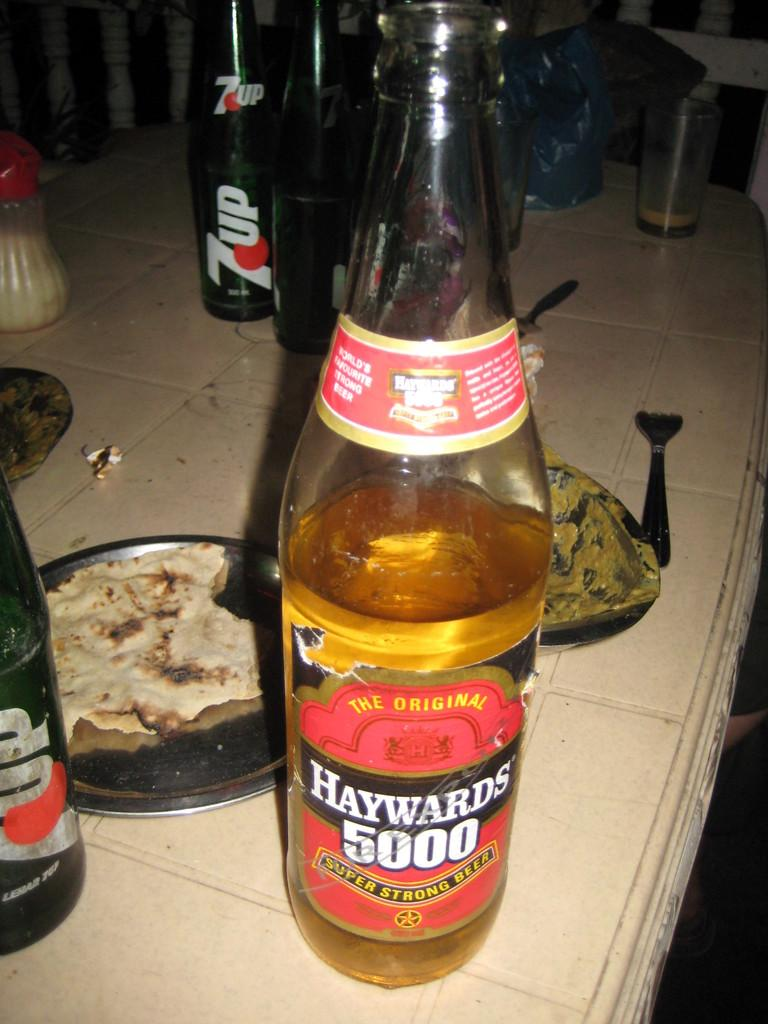<image>
Provide a brief description of the given image. Haywards 5000 Super Strong Beer half-full bottle next to three 7up bottles on a tile kitchen counter. 